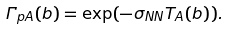Convert formula to latex. <formula><loc_0><loc_0><loc_500><loc_500>\Gamma _ { p A } ( b ) = \exp ( - \sigma _ { N N } T _ { A } ( b ) ) .</formula> 